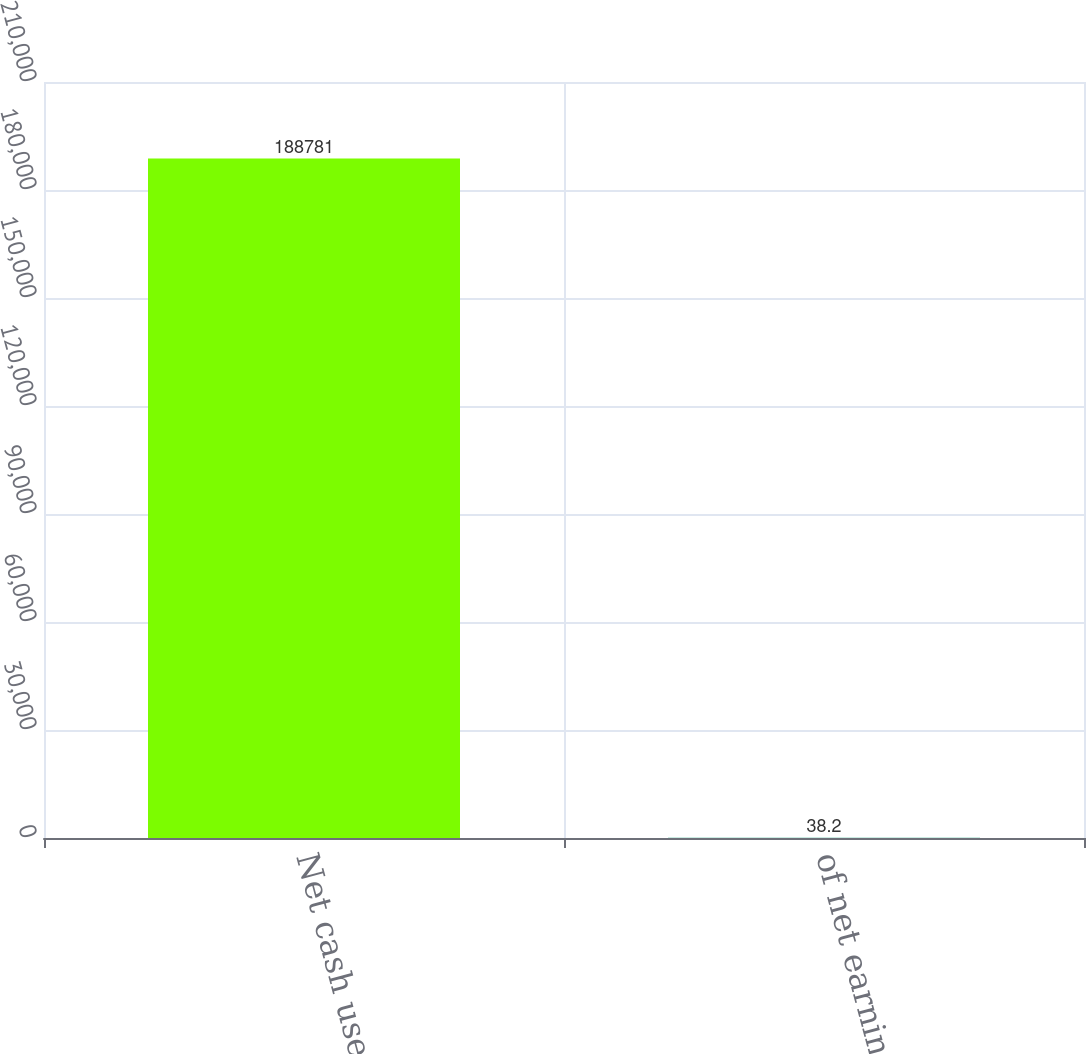Convert chart to OTSL. <chart><loc_0><loc_0><loc_500><loc_500><bar_chart><fcel>Net cash used<fcel>of net earnings<nl><fcel>188781<fcel>38.2<nl></chart> 